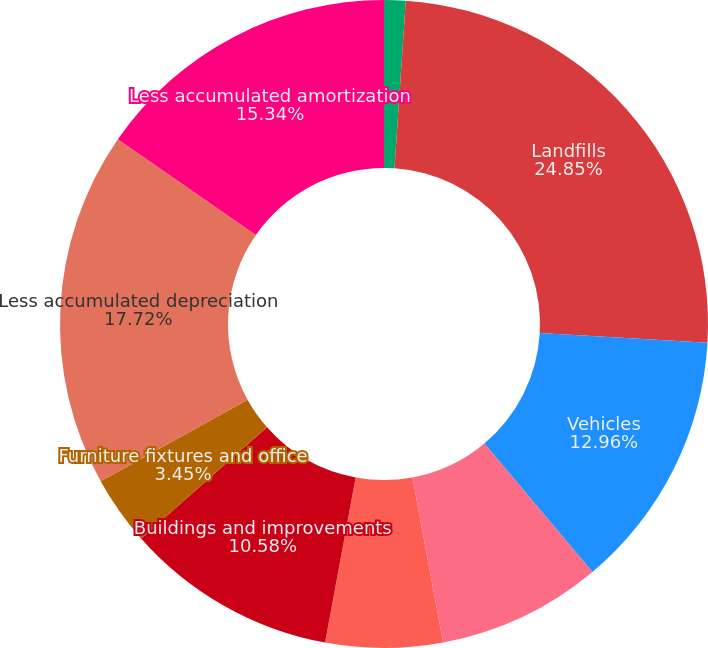<chart> <loc_0><loc_0><loc_500><loc_500><pie_chart><fcel>Land<fcel>Landfills<fcel>Vehicles<fcel>Machinery and equipment<fcel>Containers<fcel>Buildings and improvements<fcel>Furniture fixtures and office<fcel>Less accumulated depreciation<fcel>Less accumulated amortization<nl><fcel>1.07%<fcel>24.85%<fcel>12.96%<fcel>8.2%<fcel>5.83%<fcel>10.58%<fcel>3.45%<fcel>17.72%<fcel>15.34%<nl></chart> 